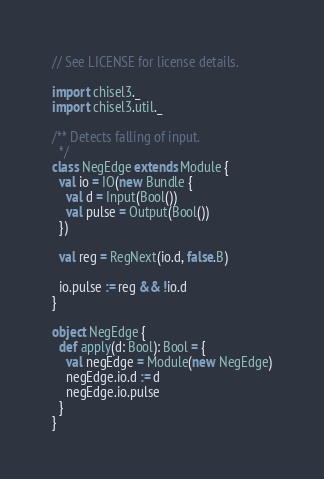<code> <loc_0><loc_0><loc_500><loc_500><_Scala_>// See LICENSE for license details.

import chisel3._
import chisel3.util._

/** Detects falling of input.
  */
class NegEdge extends Module {
  val io = IO(new Bundle {
    val d = Input(Bool())
    val pulse = Output(Bool())
  })

  val reg = RegNext(io.d, false.B)

  io.pulse := reg && !io.d
}

object NegEdge {
  def apply(d: Bool): Bool = {
    val negEdge = Module(new NegEdge)
    negEdge.io.d := d
    negEdge.io.pulse
  }
}
</code> 